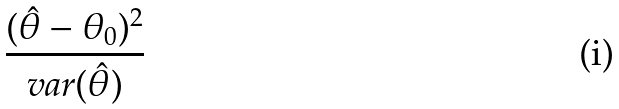<formula> <loc_0><loc_0><loc_500><loc_500>\frac { ( \hat { \theta } - \theta _ { 0 } ) ^ { 2 } } { v a r ( \hat { \theta } ) }</formula> 